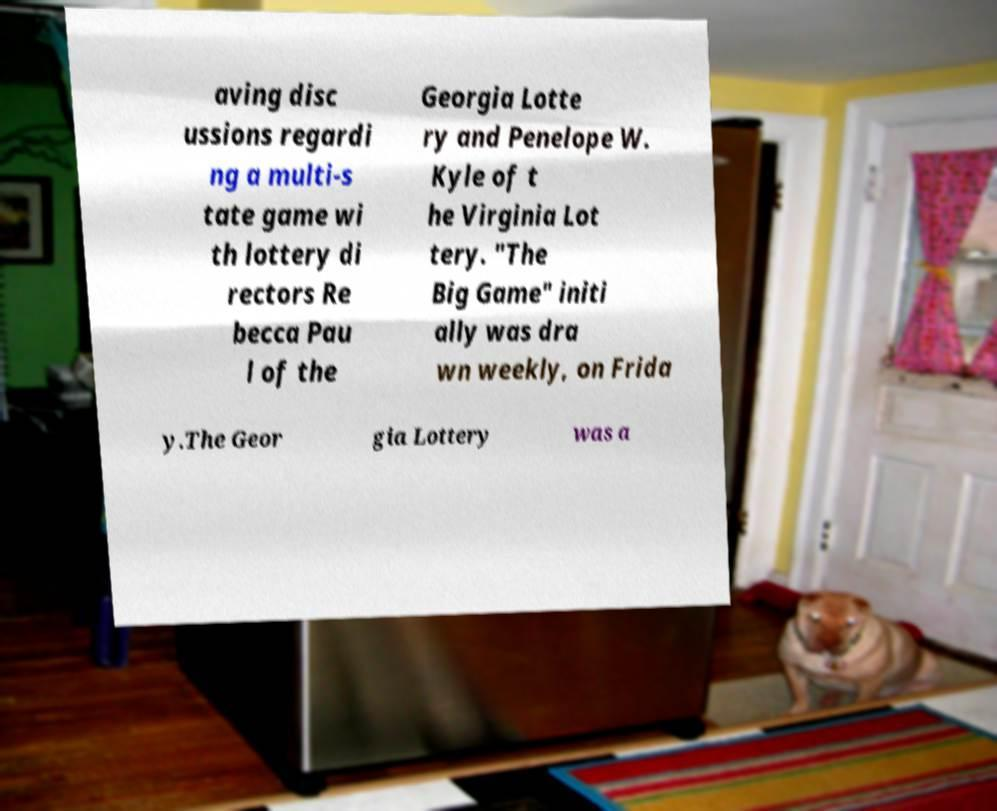I need the written content from this picture converted into text. Can you do that? aving disc ussions regardi ng a multi-s tate game wi th lottery di rectors Re becca Pau l of the Georgia Lotte ry and Penelope W. Kyle of t he Virginia Lot tery. "The Big Game" initi ally was dra wn weekly, on Frida y.The Geor gia Lottery was a 